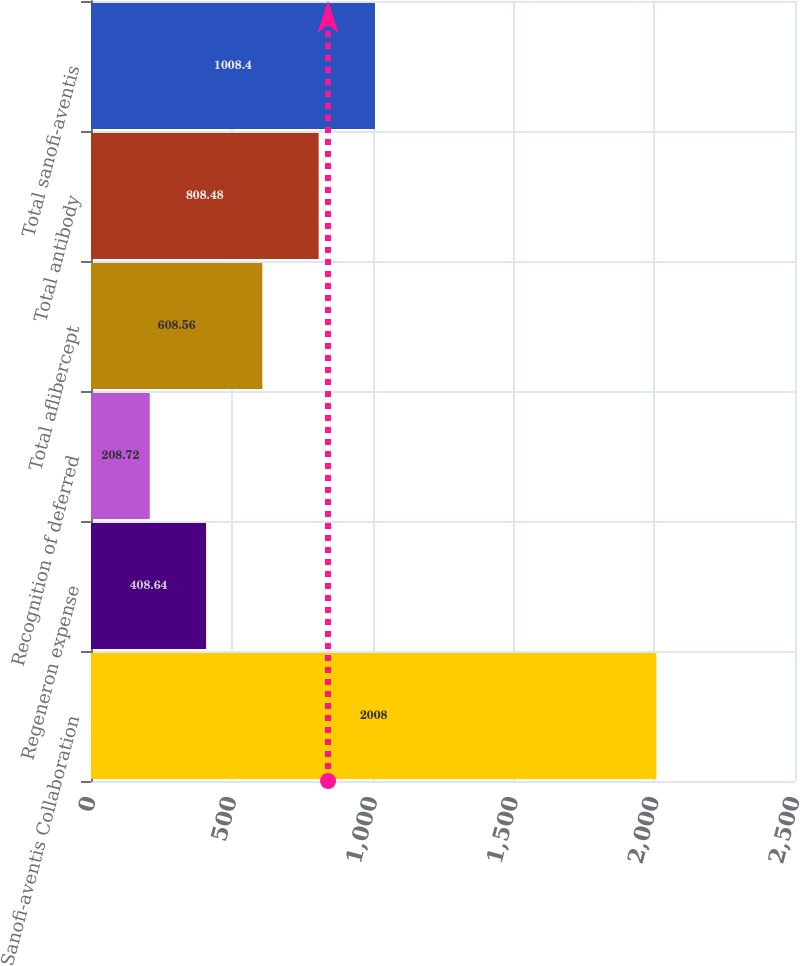Convert chart to OTSL. <chart><loc_0><loc_0><loc_500><loc_500><bar_chart><fcel>Sanofi-aventis Collaboration<fcel>Regeneron expense<fcel>Recognition of deferred<fcel>Total aflibercept<fcel>Total antibody<fcel>Total sanofi-aventis<nl><fcel>2008<fcel>408.64<fcel>208.72<fcel>608.56<fcel>808.48<fcel>1008.4<nl></chart> 